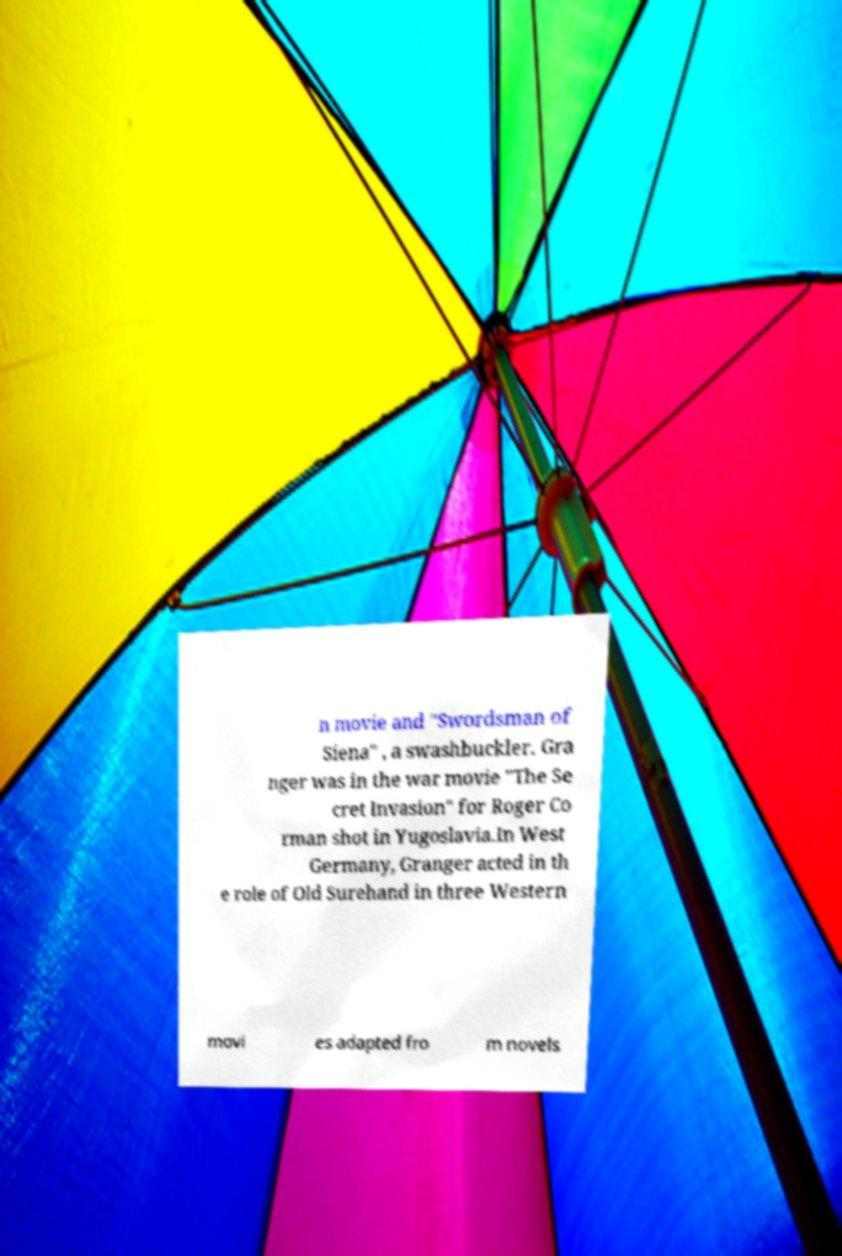I need the written content from this picture converted into text. Can you do that? n movie and "Swordsman of Siena" , a swashbuckler. Gra nger was in the war movie "The Se cret Invasion" for Roger Co rman shot in Yugoslavia.In West Germany, Granger acted in th e role of Old Surehand in three Western movi es adapted fro m novels 